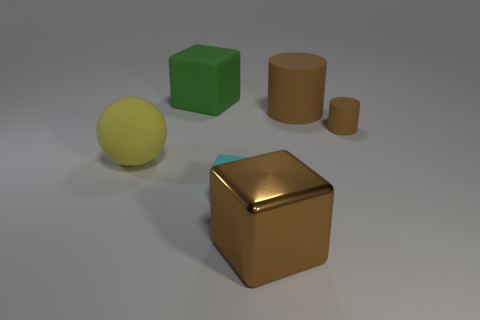The cyan rubber thing is what shape?
Provide a short and direct response. Cube. What number of other objects are the same shape as the metallic thing?
Your answer should be compact. 2. There is a tiny rubber object that is to the right of the brown metallic thing; what is its color?
Make the answer very short. Brown. Are the tiny brown object and the brown cube made of the same material?
Offer a very short reply. No. What number of objects are either big metal things or small things that are in front of the big yellow matte object?
Offer a terse response. 2. There is another cylinder that is the same color as the large rubber cylinder; what size is it?
Your response must be concise. Small. There is a large rubber thing that is on the right side of the large matte block; what is its shape?
Your answer should be very brief. Cylinder. There is a small matte thing that is in front of the big yellow object; is its color the same as the big cylinder?
Your answer should be compact. No. What is the material of the small cylinder that is the same color as the large cylinder?
Ensure brevity in your answer.  Rubber. Is the size of the matte block behind the yellow thing the same as the cyan cube?
Your response must be concise. No. 